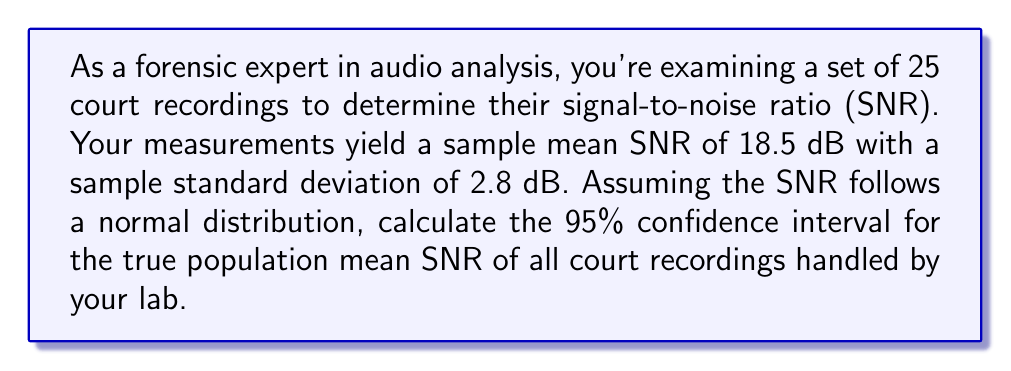Teach me how to tackle this problem. To calculate the confidence interval, we'll follow these steps:

1. Identify the known values:
   - Sample size: $n = 25$
   - Sample mean: $\bar{x} = 18.5$ dB
   - Sample standard deviation: $s = 2.8$ dB
   - Confidence level: 95% (α = 0.05)

2. Determine the critical value:
   For a 95% confidence interval with 24 degrees of freedom (n-1), we use the t-distribution. The critical value is $t_{0.025,24} = 2.064$ (from t-distribution table).

3. Calculate the margin of error:
   Margin of error = $t_{0.025,24} \cdot \frac{s}{\sqrt{n}}$
   $$ \text{Margin of error} = 2.064 \cdot \frac{2.8}{\sqrt{25}} = 1.16 \text{ dB} $$

4. Compute the confidence interval:
   Lower bound = $\bar{x} - \text{Margin of error}$
   Upper bound = $\bar{x} + \text{Margin of error}$

   $$ 18.5 - 1.16 \leq \mu \leq 18.5 + 1.16 $$
   $$ 17.34 \text{ dB} \leq \mu \leq 19.66 \text{ dB} $$

Therefore, we can be 95% confident that the true population mean SNR falls between 17.34 dB and 19.66 dB.
Answer: (17.34 dB, 19.66 dB) 